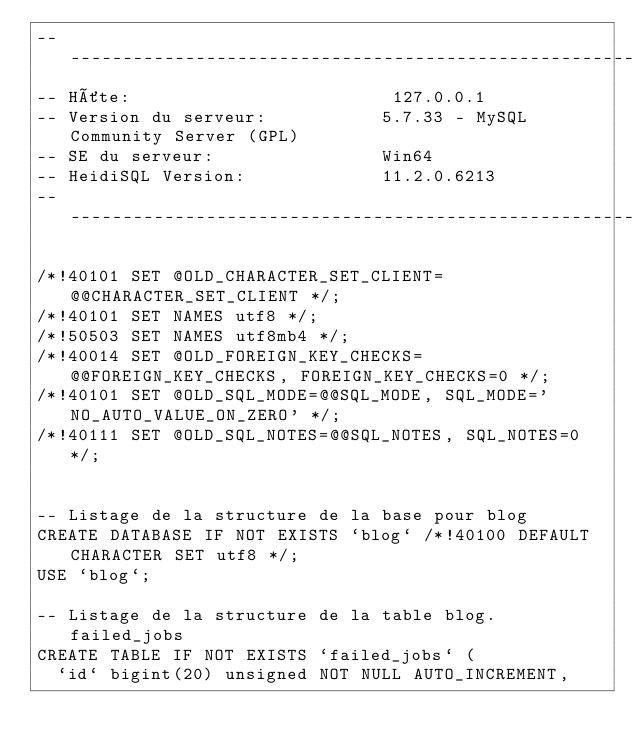Convert code to text. <code><loc_0><loc_0><loc_500><loc_500><_SQL_>-- --------------------------------------------------------
-- Hôte:                         127.0.0.1
-- Version du serveur:           5.7.33 - MySQL Community Server (GPL)
-- SE du serveur:                Win64
-- HeidiSQL Version:             11.2.0.6213
-- --------------------------------------------------------

/*!40101 SET @OLD_CHARACTER_SET_CLIENT=@@CHARACTER_SET_CLIENT */;
/*!40101 SET NAMES utf8 */;
/*!50503 SET NAMES utf8mb4 */;
/*!40014 SET @OLD_FOREIGN_KEY_CHECKS=@@FOREIGN_KEY_CHECKS, FOREIGN_KEY_CHECKS=0 */;
/*!40101 SET @OLD_SQL_MODE=@@SQL_MODE, SQL_MODE='NO_AUTO_VALUE_ON_ZERO' */;
/*!40111 SET @OLD_SQL_NOTES=@@SQL_NOTES, SQL_NOTES=0 */;


-- Listage de la structure de la base pour blog
CREATE DATABASE IF NOT EXISTS `blog` /*!40100 DEFAULT CHARACTER SET utf8 */;
USE `blog`;

-- Listage de la structure de la table blog. failed_jobs
CREATE TABLE IF NOT EXISTS `failed_jobs` (
  `id` bigint(20) unsigned NOT NULL AUTO_INCREMENT,</code> 